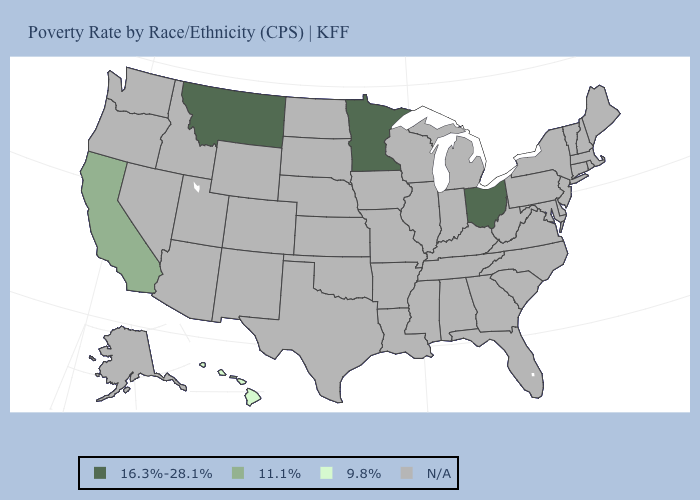Which states have the lowest value in the MidWest?
Be succinct. Minnesota, Ohio. Does the map have missing data?
Give a very brief answer. Yes. Name the states that have a value in the range 16.3%-28.1%?
Short answer required. Minnesota, Montana, Ohio. Does Montana have the highest value in the West?
Concise answer only. Yes. Which states have the highest value in the USA?
Keep it brief. Minnesota, Montana, Ohio. What is the value of Vermont?
Answer briefly. N/A. Name the states that have a value in the range 11.1%?
Write a very short answer. California. What is the value of Delaware?
Keep it brief. N/A. What is the lowest value in states that border Iowa?
Keep it brief. 16.3%-28.1%. What is the lowest value in the USA?
Write a very short answer. 9.8%. 